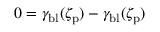Convert formula to latex. <formula><loc_0><loc_0><loc_500><loc_500>0 = \gamma _ { b l } ( \zeta _ { p } ) - \gamma _ { b l } ( \zeta _ { p } )</formula> 